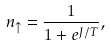<formula> <loc_0><loc_0><loc_500><loc_500>n _ { \uparrow } = \frac { 1 } { 1 + e ^ { J / T } } ,</formula> 